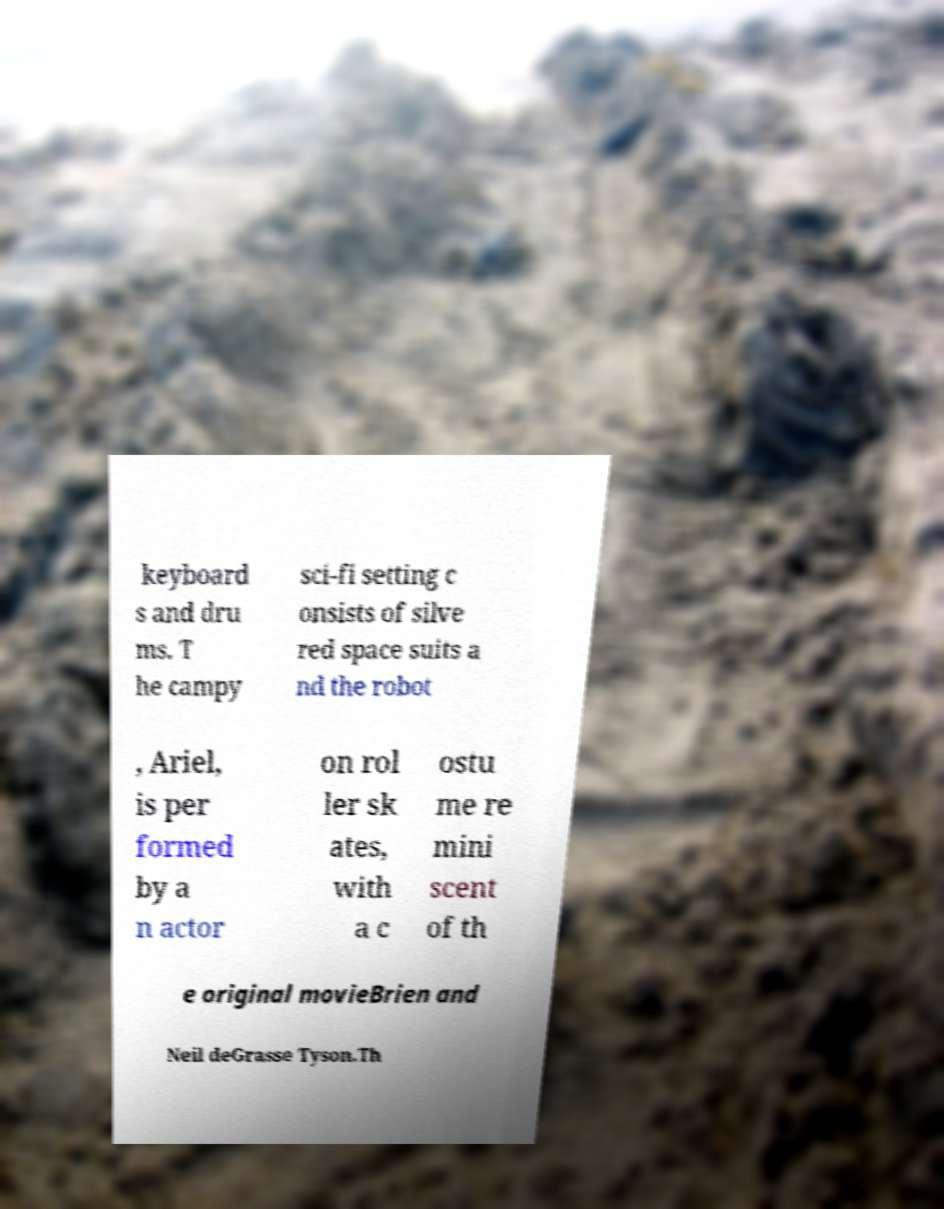For documentation purposes, I need the text within this image transcribed. Could you provide that? keyboard s and dru ms. T he campy sci-fi setting c onsists of silve red space suits a nd the robot , Ariel, is per formed by a n actor on rol ler sk ates, with a c ostu me re mini scent of th e original movieBrien and Neil deGrasse Tyson.Th 